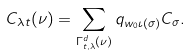Convert formula to latex. <formula><loc_0><loc_0><loc_500><loc_500>C _ { \lambda t } ( \nu ) = \sum _ { \Gamma ^ { d } _ { t , \lambda } ( \nu ) } q _ { w _ { 0 } \iota ( \sigma ) } C _ { \sigma } .</formula> 